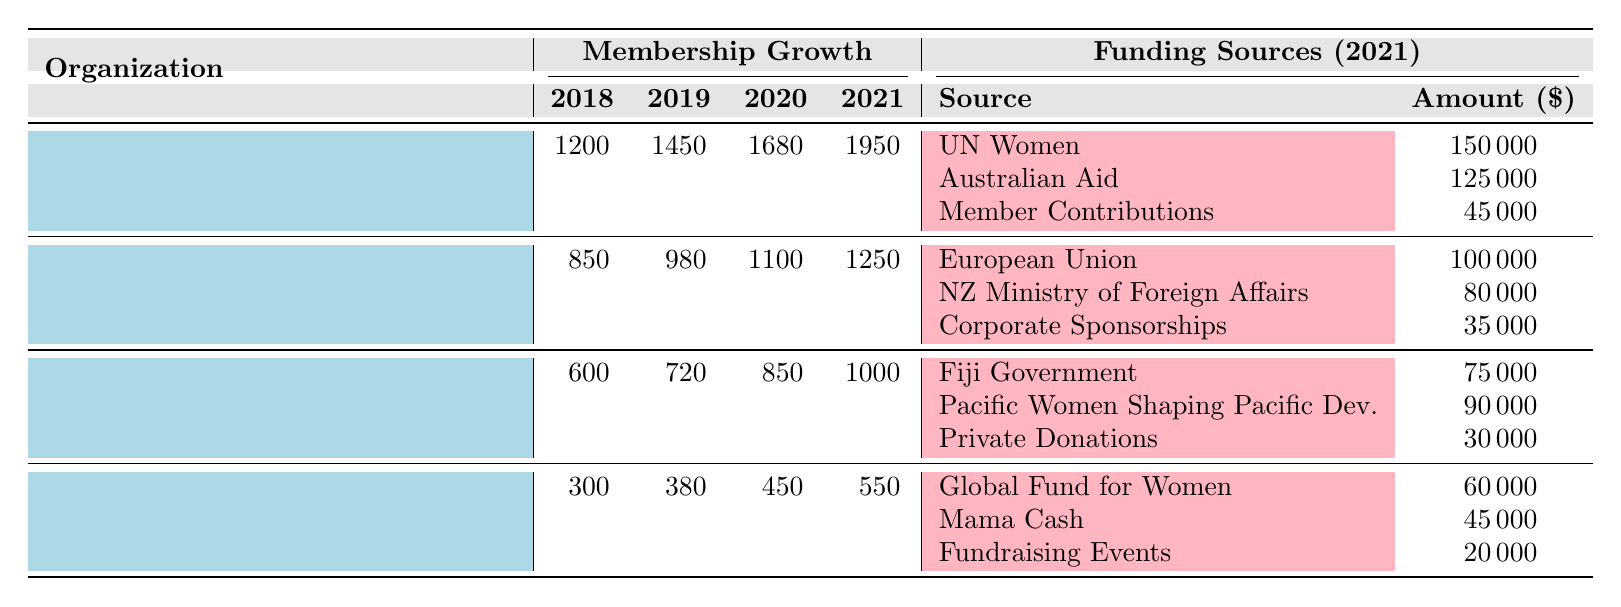What was the membership of femLINKpacific in 2021? The table shows that femLINKpacific had 1250 members in 2021.
Answer: 1250 Which organization had the highest membership growth between 2018 and 2021? The Fiji Women's Rights Movement went from 1200 members in 2018 to 1950 in 2021, yielding a growth of 750 members. In contrast, the other organizations had lower growths: femLINKpacific (400), Fiji Women's Crisis Center (400), and Diverse Voices and Action for Equality (250).
Answer: Fiji Women's Rights Movement What is the total amount of funding received by the Fiji Women's Crisis Center in 2021? Summing the funding sources: 75000 + 90000 + 30000 gives us 195000 in total.
Answer: 195000 Did any organization have a decline in membership between 2018 and 2021? The table lists increasing membership for all organizations from 2018 to 2021, showing no declines.
Answer: No What was the average number of members in 2021 across all organizations listed? In 2021, the organizations had the following memberships: 1950, 1250, 1000, and 550. The total is 3950, and dividing by 4 gives us an average of 987.5.
Answer: 987.5 Which funding source provided the least amount of funding to the Diverse Voices and Action for Equality? The funding sources for this organization are: Global Fund for Women (60000), Mama Cash (45000), and Fundraising Events (20000). The least amount is from Fundraising Events.
Answer: Fundraising Events What was the total membership for all organizations in 2020? The memberships for 2020 were: 1680 (Fiji Women's Rights Movement), 1100 (femLINKpacific), 850 (Fiji Women's Crisis Center), and 450 (Diverse Voices and Action for Equality). The total is 1680 + 1100 + 850 + 450 = 4080.
Answer: 4080 Which organization received funding from UN Women? The table shows that only the Fiji Women's Rights Movement received funding from UN Women.
Answer: Fiji Women's Rights Movement What was the increase in membership for Diverse Voices and Action for Equality from 2018 to 2021? The organization had 300 members in 2018 and 550 members in 2021. The increase is 550 - 300 = 250 members.
Answer: 250 Is the amount funded by the European Union to femLINKpacific more than the total amount funded by the Fiji Government and Pacific Women Shaping Pacific Development to the Fiji Women's Crisis Center? The European Union provided 100000 to femLINKpacific, while the Fiji Government and Pacific Women provided a total of 75000 + 90000 = 165000. Since 100000 is less than 165000, the statement is false.
Answer: No 